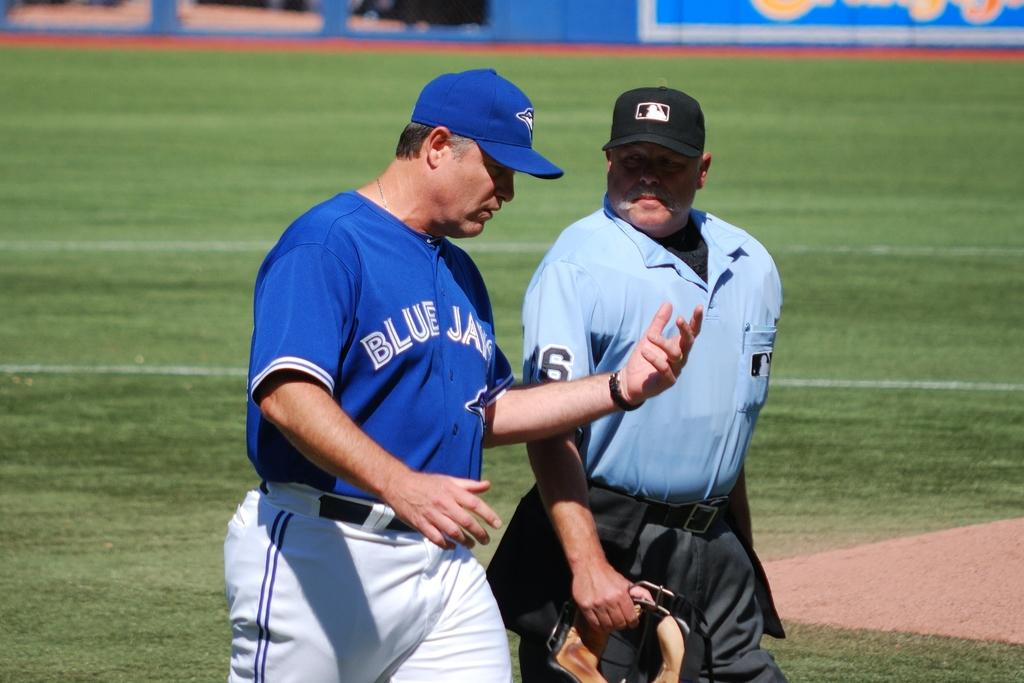Provide a one-sentence caption for the provided image. A Blue Jays manager has a conversation with an umpire wearing a number 6. 